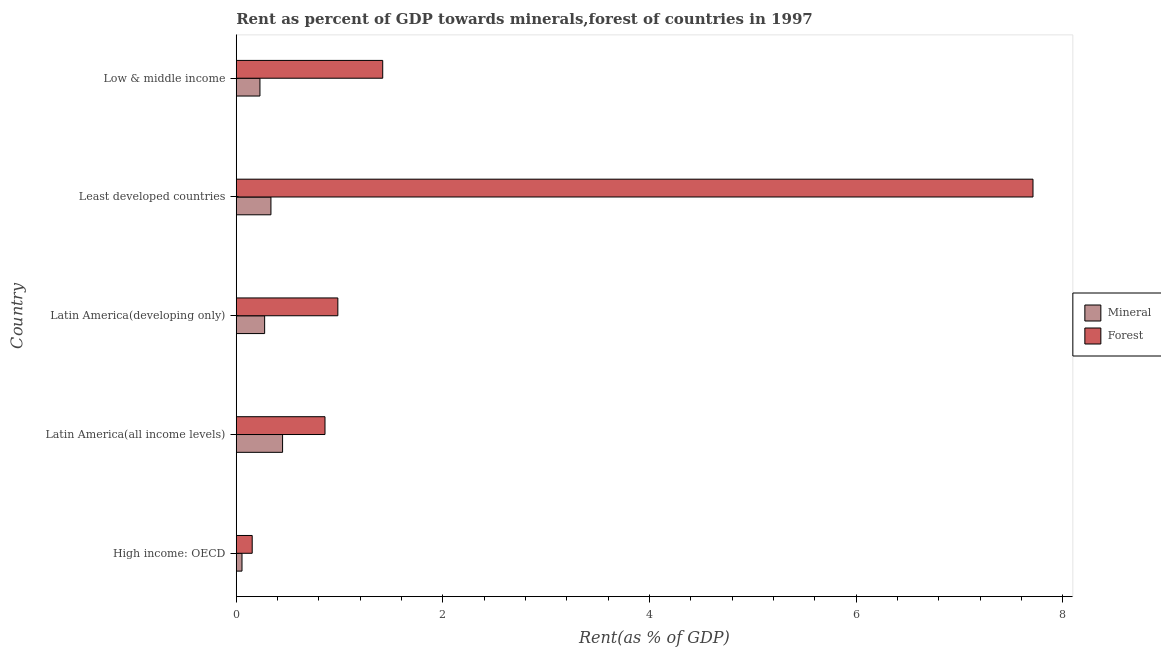How many different coloured bars are there?
Ensure brevity in your answer.  2. Are the number of bars per tick equal to the number of legend labels?
Your answer should be very brief. Yes. Are the number of bars on each tick of the Y-axis equal?
Ensure brevity in your answer.  Yes. What is the label of the 4th group of bars from the top?
Offer a very short reply. Latin America(all income levels). What is the forest rent in Least developed countries?
Ensure brevity in your answer.  7.71. Across all countries, what is the maximum mineral rent?
Offer a very short reply. 0.45. Across all countries, what is the minimum mineral rent?
Make the answer very short. 0.06. In which country was the mineral rent maximum?
Offer a terse response. Latin America(all income levels). In which country was the mineral rent minimum?
Offer a terse response. High income: OECD. What is the total forest rent in the graph?
Ensure brevity in your answer.  11.13. What is the difference between the mineral rent in High income: OECD and that in Latin America(developing only)?
Provide a short and direct response. -0.22. What is the difference between the forest rent in High income: OECD and the mineral rent in Latin America(developing only)?
Offer a terse response. -0.12. What is the average forest rent per country?
Provide a short and direct response. 2.23. What is the difference between the forest rent and mineral rent in Low & middle income?
Make the answer very short. 1.19. What is the ratio of the mineral rent in Latin America(all income levels) to that in Latin America(developing only)?
Provide a short and direct response. 1.63. Is the mineral rent in Latin America(developing only) less than that in Least developed countries?
Provide a succinct answer. Yes. Is the difference between the mineral rent in Latin America(all income levels) and Low & middle income greater than the difference between the forest rent in Latin America(all income levels) and Low & middle income?
Offer a very short reply. Yes. What is the difference between the highest and the second highest forest rent?
Your answer should be compact. 6.29. What is the difference between the highest and the lowest forest rent?
Make the answer very short. 7.56. In how many countries, is the mineral rent greater than the average mineral rent taken over all countries?
Provide a succinct answer. 3. Is the sum of the forest rent in High income: OECD and Least developed countries greater than the maximum mineral rent across all countries?
Your answer should be very brief. Yes. What does the 1st bar from the top in Latin America(all income levels) represents?
Provide a short and direct response. Forest. What does the 1st bar from the bottom in Latin America(developing only) represents?
Ensure brevity in your answer.  Mineral. How many bars are there?
Make the answer very short. 10. Are all the bars in the graph horizontal?
Make the answer very short. Yes. How many countries are there in the graph?
Provide a short and direct response. 5. What is the difference between two consecutive major ticks on the X-axis?
Keep it short and to the point. 2. Does the graph contain grids?
Keep it short and to the point. No. How are the legend labels stacked?
Your response must be concise. Vertical. What is the title of the graph?
Your answer should be very brief. Rent as percent of GDP towards minerals,forest of countries in 1997. What is the label or title of the X-axis?
Provide a short and direct response. Rent(as % of GDP). What is the Rent(as % of GDP) of Mineral in High income: OECD?
Ensure brevity in your answer.  0.06. What is the Rent(as % of GDP) in Forest in High income: OECD?
Your answer should be compact. 0.15. What is the Rent(as % of GDP) in Mineral in Latin America(all income levels)?
Your answer should be very brief. 0.45. What is the Rent(as % of GDP) in Forest in Latin America(all income levels)?
Keep it short and to the point. 0.86. What is the Rent(as % of GDP) of Mineral in Latin America(developing only)?
Offer a terse response. 0.27. What is the Rent(as % of GDP) in Forest in Latin America(developing only)?
Provide a succinct answer. 0.98. What is the Rent(as % of GDP) of Mineral in Least developed countries?
Provide a succinct answer. 0.34. What is the Rent(as % of GDP) in Forest in Least developed countries?
Provide a short and direct response. 7.71. What is the Rent(as % of GDP) in Mineral in Low & middle income?
Provide a succinct answer. 0.23. What is the Rent(as % of GDP) in Forest in Low & middle income?
Your response must be concise. 1.42. Across all countries, what is the maximum Rent(as % of GDP) of Mineral?
Keep it short and to the point. 0.45. Across all countries, what is the maximum Rent(as % of GDP) of Forest?
Offer a very short reply. 7.71. Across all countries, what is the minimum Rent(as % of GDP) in Mineral?
Your response must be concise. 0.06. Across all countries, what is the minimum Rent(as % of GDP) of Forest?
Your response must be concise. 0.15. What is the total Rent(as % of GDP) in Mineral in the graph?
Your answer should be very brief. 1.34. What is the total Rent(as % of GDP) of Forest in the graph?
Your answer should be compact. 11.13. What is the difference between the Rent(as % of GDP) in Mineral in High income: OECD and that in Latin America(all income levels)?
Keep it short and to the point. -0.39. What is the difference between the Rent(as % of GDP) of Forest in High income: OECD and that in Latin America(all income levels)?
Your response must be concise. -0.7. What is the difference between the Rent(as % of GDP) in Mineral in High income: OECD and that in Latin America(developing only)?
Your answer should be very brief. -0.22. What is the difference between the Rent(as % of GDP) of Forest in High income: OECD and that in Latin America(developing only)?
Your answer should be very brief. -0.83. What is the difference between the Rent(as % of GDP) in Mineral in High income: OECD and that in Least developed countries?
Offer a very short reply. -0.28. What is the difference between the Rent(as % of GDP) of Forest in High income: OECD and that in Least developed countries?
Make the answer very short. -7.56. What is the difference between the Rent(as % of GDP) of Mineral in High income: OECD and that in Low & middle income?
Your answer should be compact. -0.17. What is the difference between the Rent(as % of GDP) in Forest in High income: OECD and that in Low & middle income?
Provide a short and direct response. -1.26. What is the difference between the Rent(as % of GDP) of Mineral in Latin America(all income levels) and that in Latin America(developing only)?
Make the answer very short. 0.17. What is the difference between the Rent(as % of GDP) of Forest in Latin America(all income levels) and that in Latin America(developing only)?
Offer a terse response. -0.12. What is the difference between the Rent(as % of GDP) in Mineral in Latin America(all income levels) and that in Least developed countries?
Your response must be concise. 0.11. What is the difference between the Rent(as % of GDP) of Forest in Latin America(all income levels) and that in Least developed countries?
Provide a short and direct response. -6.85. What is the difference between the Rent(as % of GDP) of Mineral in Latin America(all income levels) and that in Low & middle income?
Provide a succinct answer. 0.22. What is the difference between the Rent(as % of GDP) in Forest in Latin America(all income levels) and that in Low & middle income?
Offer a terse response. -0.56. What is the difference between the Rent(as % of GDP) of Mineral in Latin America(developing only) and that in Least developed countries?
Your answer should be very brief. -0.06. What is the difference between the Rent(as % of GDP) of Forest in Latin America(developing only) and that in Least developed countries?
Keep it short and to the point. -6.73. What is the difference between the Rent(as % of GDP) in Mineral in Latin America(developing only) and that in Low & middle income?
Make the answer very short. 0.05. What is the difference between the Rent(as % of GDP) in Forest in Latin America(developing only) and that in Low & middle income?
Keep it short and to the point. -0.43. What is the difference between the Rent(as % of GDP) of Mineral in Least developed countries and that in Low & middle income?
Give a very brief answer. 0.11. What is the difference between the Rent(as % of GDP) in Forest in Least developed countries and that in Low & middle income?
Ensure brevity in your answer.  6.29. What is the difference between the Rent(as % of GDP) of Mineral in High income: OECD and the Rent(as % of GDP) of Forest in Latin America(all income levels)?
Offer a very short reply. -0.8. What is the difference between the Rent(as % of GDP) of Mineral in High income: OECD and the Rent(as % of GDP) of Forest in Latin America(developing only)?
Offer a terse response. -0.93. What is the difference between the Rent(as % of GDP) in Mineral in High income: OECD and the Rent(as % of GDP) in Forest in Least developed countries?
Give a very brief answer. -7.66. What is the difference between the Rent(as % of GDP) in Mineral in High income: OECD and the Rent(as % of GDP) in Forest in Low & middle income?
Provide a succinct answer. -1.36. What is the difference between the Rent(as % of GDP) of Mineral in Latin America(all income levels) and the Rent(as % of GDP) of Forest in Latin America(developing only)?
Provide a succinct answer. -0.54. What is the difference between the Rent(as % of GDP) of Mineral in Latin America(all income levels) and the Rent(as % of GDP) of Forest in Least developed countries?
Your answer should be very brief. -7.26. What is the difference between the Rent(as % of GDP) in Mineral in Latin America(all income levels) and the Rent(as % of GDP) in Forest in Low & middle income?
Give a very brief answer. -0.97. What is the difference between the Rent(as % of GDP) in Mineral in Latin America(developing only) and the Rent(as % of GDP) in Forest in Least developed countries?
Provide a succinct answer. -7.44. What is the difference between the Rent(as % of GDP) in Mineral in Latin America(developing only) and the Rent(as % of GDP) in Forest in Low & middle income?
Ensure brevity in your answer.  -1.14. What is the difference between the Rent(as % of GDP) of Mineral in Least developed countries and the Rent(as % of GDP) of Forest in Low & middle income?
Make the answer very short. -1.08. What is the average Rent(as % of GDP) in Mineral per country?
Ensure brevity in your answer.  0.27. What is the average Rent(as % of GDP) of Forest per country?
Your answer should be compact. 2.23. What is the difference between the Rent(as % of GDP) of Mineral and Rent(as % of GDP) of Forest in High income: OECD?
Your response must be concise. -0.1. What is the difference between the Rent(as % of GDP) of Mineral and Rent(as % of GDP) of Forest in Latin America(all income levels)?
Make the answer very short. -0.41. What is the difference between the Rent(as % of GDP) in Mineral and Rent(as % of GDP) in Forest in Latin America(developing only)?
Provide a short and direct response. -0.71. What is the difference between the Rent(as % of GDP) in Mineral and Rent(as % of GDP) in Forest in Least developed countries?
Offer a very short reply. -7.38. What is the difference between the Rent(as % of GDP) in Mineral and Rent(as % of GDP) in Forest in Low & middle income?
Provide a succinct answer. -1.19. What is the ratio of the Rent(as % of GDP) in Mineral in High income: OECD to that in Latin America(all income levels)?
Your answer should be very brief. 0.12. What is the ratio of the Rent(as % of GDP) in Forest in High income: OECD to that in Latin America(all income levels)?
Offer a terse response. 0.18. What is the ratio of the Rent(as % of GDP) of Mineral in High income: OECD to that in Latin America(developing only)?
Keep it short and to the point. 0.2. What is the ratio of the Rent(as % of GDP) of Forest in High income: OECD to that in Latin America(developing only)?
Your response must be concise. 0.16. What is the ratio of the Rent(as % of GDP) in Mineral in High income: OECD to that in Least developed countries?
Offer a terse response. 0.17. What is the ratio of the Rent(as % of GDP) of Mineral in High income: OECD to that in Low & middle income?
Provide a short and direct response. 0.24. What is the ratio of the Rent(as % of GDP) in Forest in High income: OECD to that in Low & middle income?
Your answer should be compact. 0.11. What is the ratio of the Rent(as % of GDP) of Mineral in Latin America(all income levels) to that in Latin America(developing only)?
Ensure brevity in your answer.  1.63. What is the ratio of the Rent(as % of GDP) in Forest in Latin America(all income levels) to that in Latin America(developing only)?
Give a very brief answer. 0.87. What is the ratio of the Rent(as % of GDP) of Mineral in Latin America(all income levels) to that in Least developed countries?
Ensure brevity in your answer.  1.34. What is the ratio of the Rent(as % of GDP) of Forest in Latin America(all income levels) to that in Least developed countries?
Give a very brief answer. 0.11. What is the ratio of the Rent(as % of GDP) of Mineral in Latin America(all income levels) to that in Low & middle income?
Offer a very short reply. 1.95. What is the ratio of the Rent(as % of GDP) in Forest in Latin America(all income levels) to that in Low & middle income?
Make the answer very short. 0.61. What is the ratio of the Rent(as % of GDP) of Mineral in Latin America(developing only) to that in Least developed countries?
Your response must be concise. 0.82. What is the ratio of the Rent(as % of GDP) of Forest in Latin America(developing only) to that in Least developed countries?
Make the answer very short. 0.13. What is the ratio of the Rent(as % of GDP) in Mineral in Latin America(developing only) to that in Low & middle income?
Your response must be concise. 1.2. What is the ratio of the Rent(as % of GDP) in Forest in Latin America(developing only) to that in Low & middle income?
Provide a succinct answer. 0.69. What is the ratio of the Rent(as % of GDP) of Mineral in Least developed countries to that in Low & middle income?
Keep it short and to the point. 1.46. What is the ratio of the Rent(as % of GDP) in Forest in Least developed countries to that in Low & middle income?
Ensure brevity in your answer.  5.44. What is the difference between the highest and the second highest Rent(as % of GDP) in Mineral?
Your answer should be very brief. 0.11. What is the difference between the highest and the second highest Rent(as % of GDP) of Forest?
Provide a succinct answer. 6.29. What is the difference between the highest and the lowest Rent(as % of GDP) in Mineral?
Offer a terse response. 0.39. What is the difference between the highest and the lowest Rent(as % of GDP) in Forest?
Make the answer very short. 7.56. 